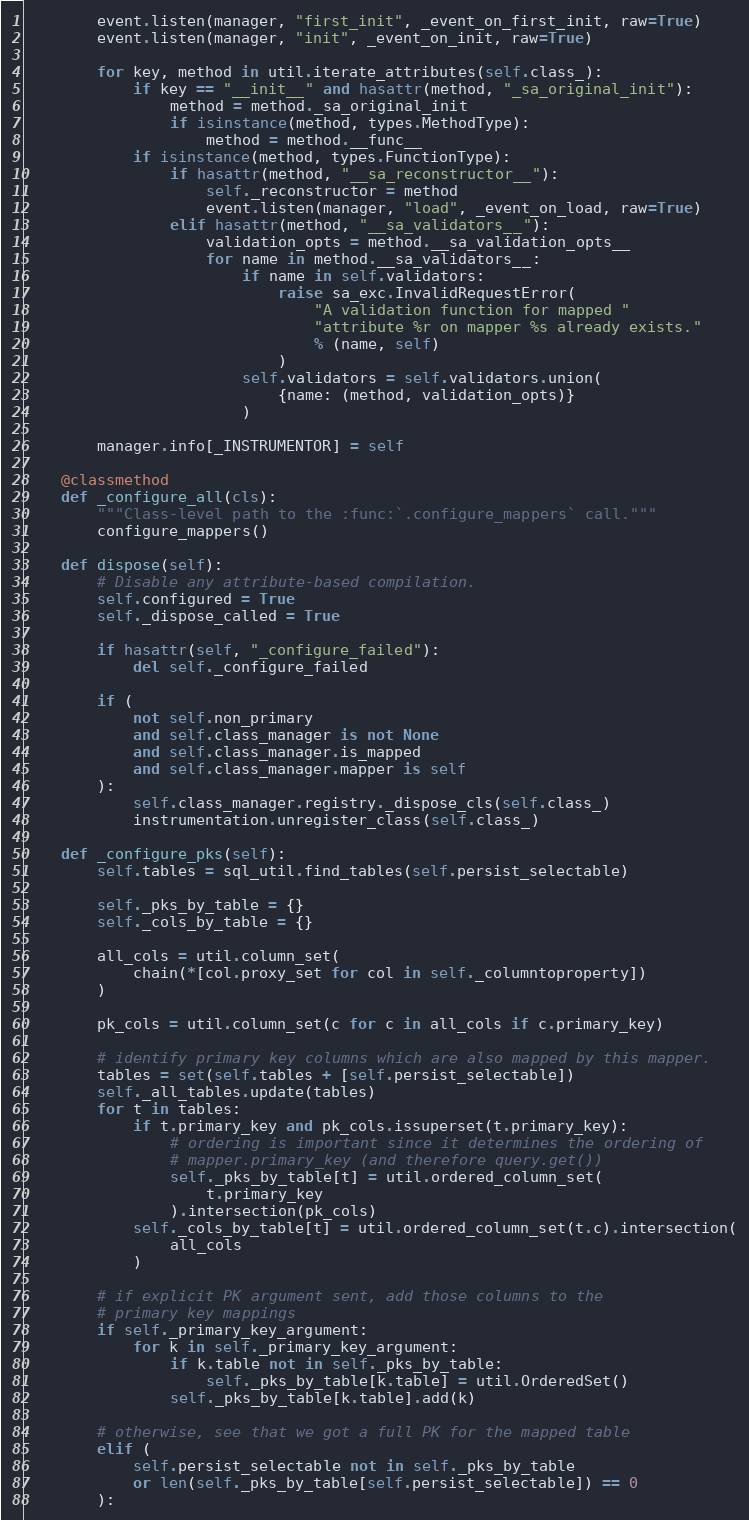<code> <loc_0><loc_0><loc_500><loc_500><_Python_>        event.listen(manager, "first_init", _event_on_first_init, raw=True)
        event.listen(manager, "init", _event_on_init, raw=True)

        for key, method in util.iterate_attributes(self.class_):
            if key == "__init__" and hasattr(method, "_sa_original_init"):
                method = method._sa_original_init
                if isinstance(method, types.MethodType):
                    method = method.__func__
            if isinstance(method, types.FunctionType):
                if hasattr(method, "__sa_reconstructor__"):
                    self._reconstructor = method
                    event.listen(manager, "load", _event_on_load, raw=True)
                elif hasattr(method, "__sa_validators__"):
                    validation_opts = method.__sa_validation_opts__
                    for name in method.__sa_validators__:
                        if name in self.validators:
                            raise sa_exc.InvalidRequestError(
                                "A validation function for mapped "
                                "attribute %r on mapper %s already exists."
                                % (name, self)
                            )
                        self.validators = self.validators.union(
                            {name: (method, validation_opts)}
                        )

        manager.info[_INSTRUMENTOR] = self

    @classmethod
    def _configure_all(cls):
        """Class-level path to the :func:`.configure_mappers` call."""
        configure_mappers()

    def dispose(self):
        # Disable any attribute-based compilation.
        self.configured = True
        self._dispose_called = True

        if hasattr(self, "_configure_failed"):
            del self._configure_failed

        if (
            not self.non_primary
            and self.class_manager is not None
            and self.class_manager.is_mapped
            and self.class_manager.mapper is self
        ):
            self.class_manager.registry._dispose_cls(self.class_)
            instrumentation.unregister_class(self.class_)

    def _configure_pks(self):
        self.tables = sql_util.find_tables(self.persist_selectable)

        self._pks_by_table = {}
        self._cols_by_table = {}

        all_cols = util.column_set(
            chain(*[col.proxy_set for col in self._columntoproperty])
        )

        pk_cols = util.column_set(c for c in all_cols if c.primary_key)

        # identify primary key columns which are also mapped by this mapper.
        tables = set(self.tables + [self.persist_selectable])
        self._all_tables.update(tables)
        for t in tables:
            if t.primary_key and pk_cols.issuperset(t.primary_key):
                # ordering is important since it determines the ordering of
                # mapper.primary_key (and therefore query.get())
                self._pks_by_table[t] = util.ordered_column_set(
                    t.primary_key
                ).intersection(pk_cols)
            self._cols_by_table[t] = util.ordered_column_set(t.c).intersection(
                all_cols
            )

        # if explicit PK argument sent, add those columns to the
        # primary key mappings
        if self._primary_key_argument:
            for k in self._primary_key_argument:
                if k.table not in self._pks_by_table:
                    self._pks_by_table[k.table] = util.OrderedSet()
                self._pks_by_table[k.table].add(k)

        # otherwise, see that we got a full PK for the mapped table
        elif (
            self.persist_selectable not in self._pks_by_table
            or len(self._pks_by_table[self.persist_selectable]) == 0
        ):</code> 